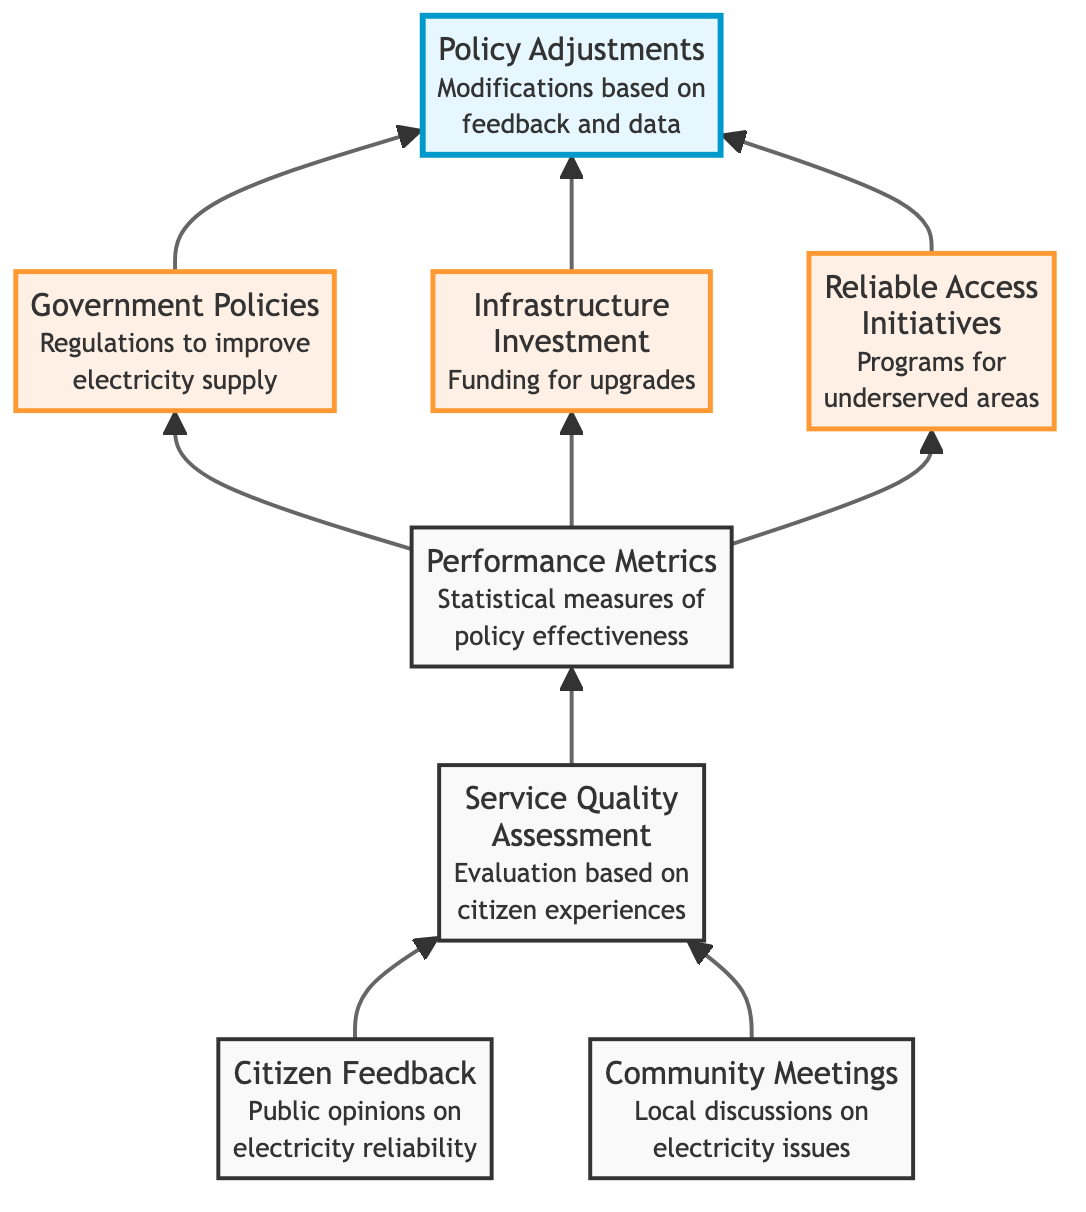What is represented by the "Citizen Feedback" node? The "Citizen Feedback" node represents public opinions and reports regarding electricity reliability and accessibility. This is explicitly described in the diagram under that node's information.
Answer: Public opinions How many nodes are in the diagram? By counting the nodes listed in the diagram, we see there are a total of eight nodes, including both top-level, mid-level, and default nodes.
Answer: Eight What is the relationship between "Community Meetings" and "Service Quality Assessment"? "Community Meetings" connects to "Service Quality Assessment" directly, indicating that discussions in community meetings lead to evaluations of service quality based on citizen experiences.
Answer: Direct connection Which node assesses the statistical measures of policy effectiveness? The node that assesses statistical measures of policy effectiveness is "Performance Metrics," as explicitly stated in the node's description.
Answer: Performance Metrics What leads to "Policy Adjustments"? "Policy Adjustments" is reached from three different nodes: "Government Policies," "Infrastructure Investment," and "Reliable Access Initiatives," which all indicate modifications based on performance metrics and citizen feedback.
Answer: Three nodes Which nodes directly contribute to the "Service Quality Assessment"? "Citizen Feedback" and "Community Meetings" are the two nodes that directly contribute to the "Service Quality Assessment," as indicated by their direct connections to it in the diagram.
Answer: Citizen Feedback and Community Meetings What can lead to improvements in electricity supply according to the diagram? Improvements in electricity supply can be achieved through "Government Policies," "Infrastructure Investment," and "Reliable Access Initiatives," based on the feedback and performance metrics outlined in the diagram.
Answer: Three initiatives Which initiatives are specifically aimed at underserved areas? The "Reliable Access Initiatives" node specifically focuses on ensuring consistent electricity access for underserved areas, as noted in its description.
Answer: Reliable Access Initiatives What influences the modifications made in "Policy Adjustments"? Modifications made in "Policy Adjustments" are influenced by "Citizen Feedback," "Performance Metrics," and results from "Government Policies" and "Infrastructure Investment."
Answer: Citizen feedback and performance metrics 